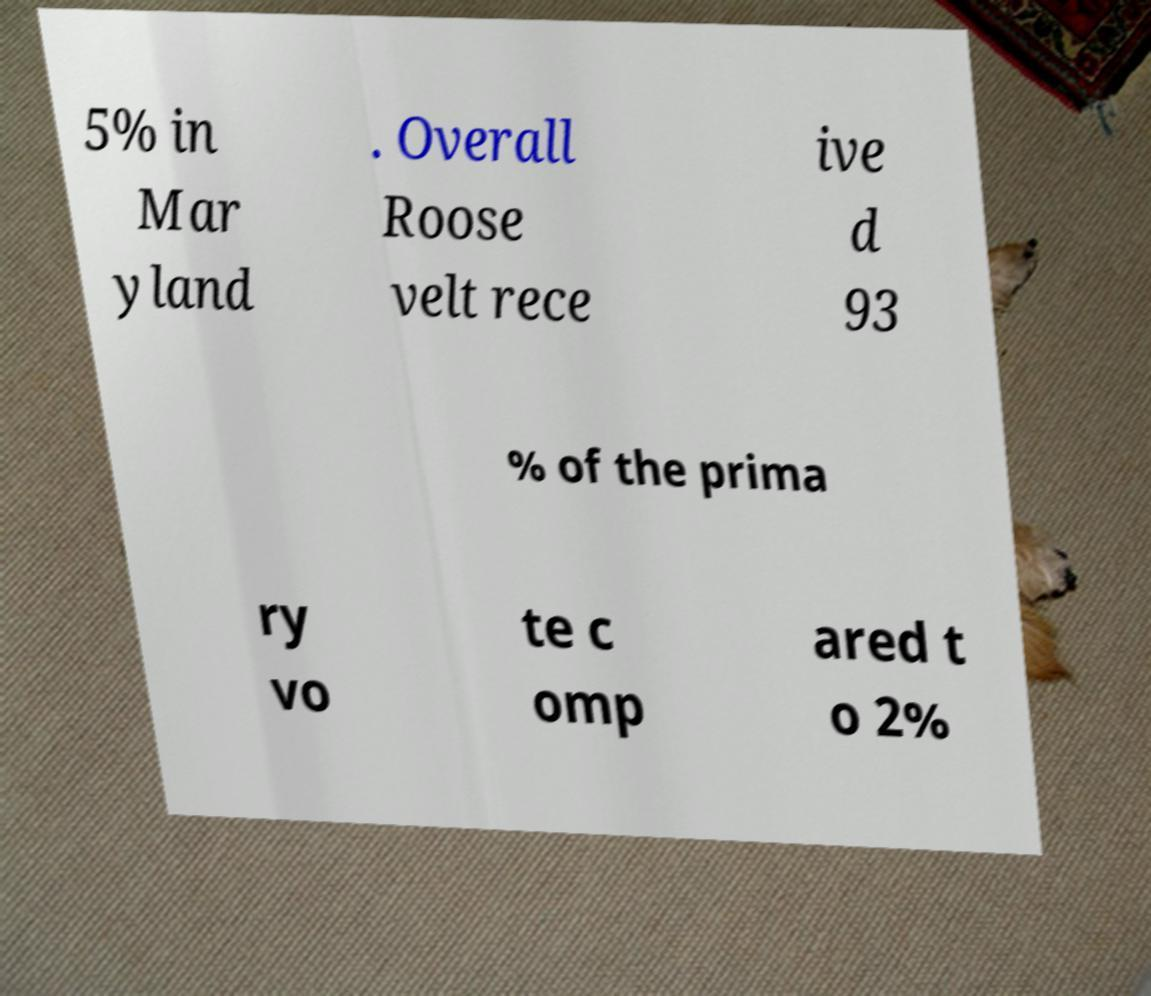Please read and relay the text visible in this image. What does it say? 5% in Mar yland . Overall Roose velt rece ive d 93 % of the prima ry vo te c omp ared t o 2% 